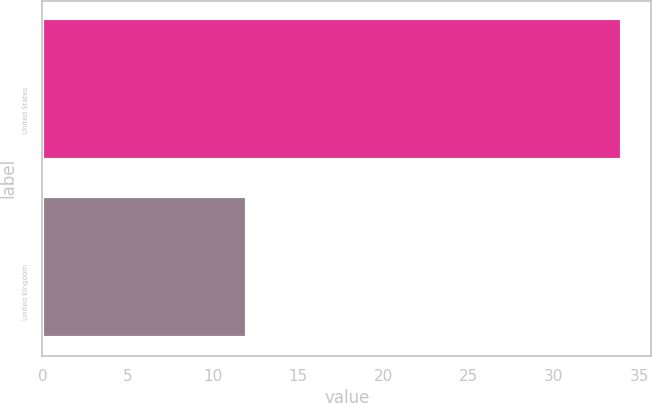<chart> <loc_0><loc_0><loc_500><loc_500><bar_chart><fcel>United States<fcel>United Kingdom<nl><fcel>34<fcel>12<nl></chart> 